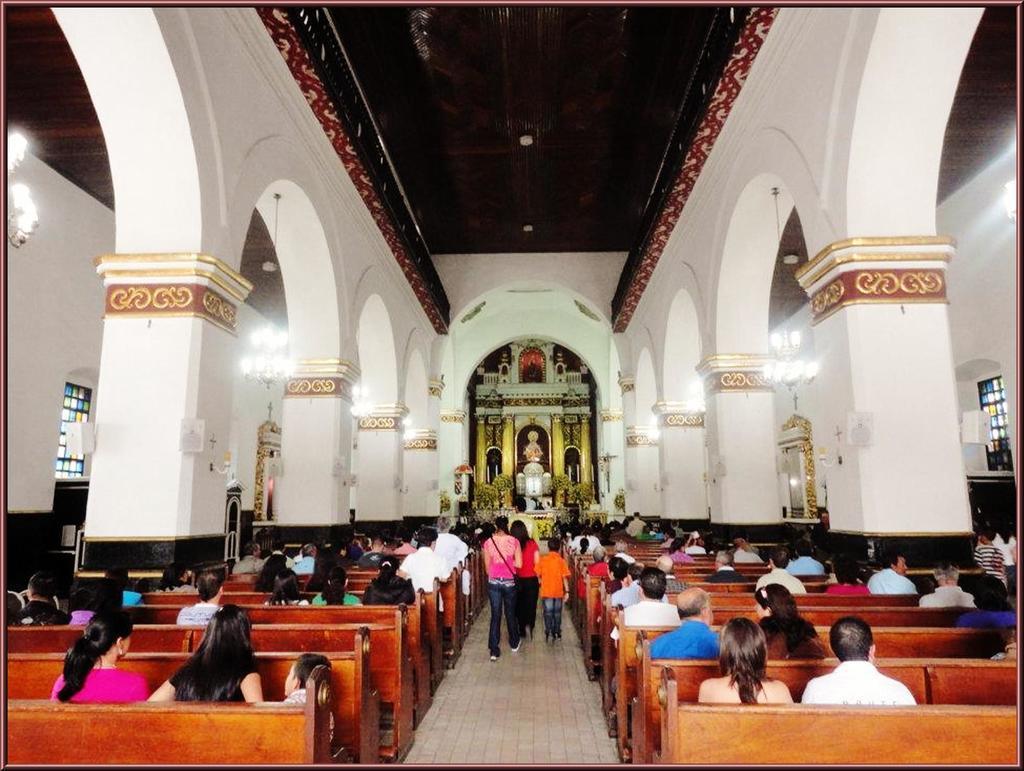Describe this image in one or two sentences. This image is taken inside a church. In the foreground of the image there are people sitting on benches. In the center of the image there are people walking. In the background of the image there are idols. There are pillars. At the top of the image there is ceiling. 